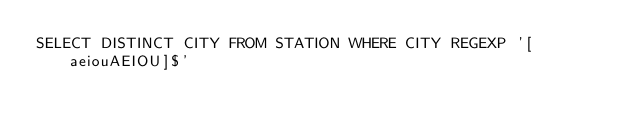Convert code to text. <code><loc_0><loc_0><loc_500><loc_500><_SQL_>SELECT DISTINCT CITY FROM STATION WHERE CITY REGEXP '[aeiouAEIOU]$'
</code> 